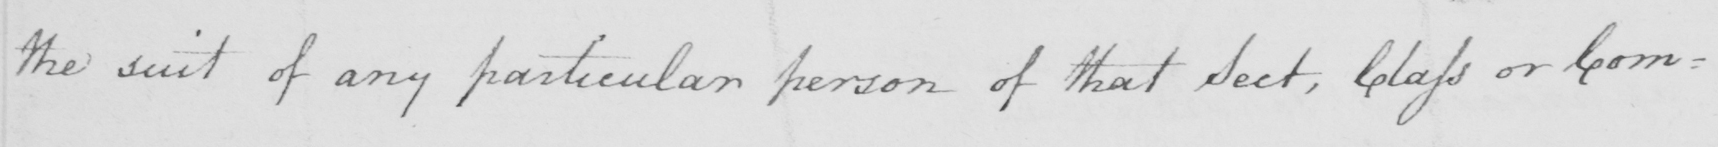What text is written in this handwritten line? the suit of any particular person of that Sect , Class or Com : 